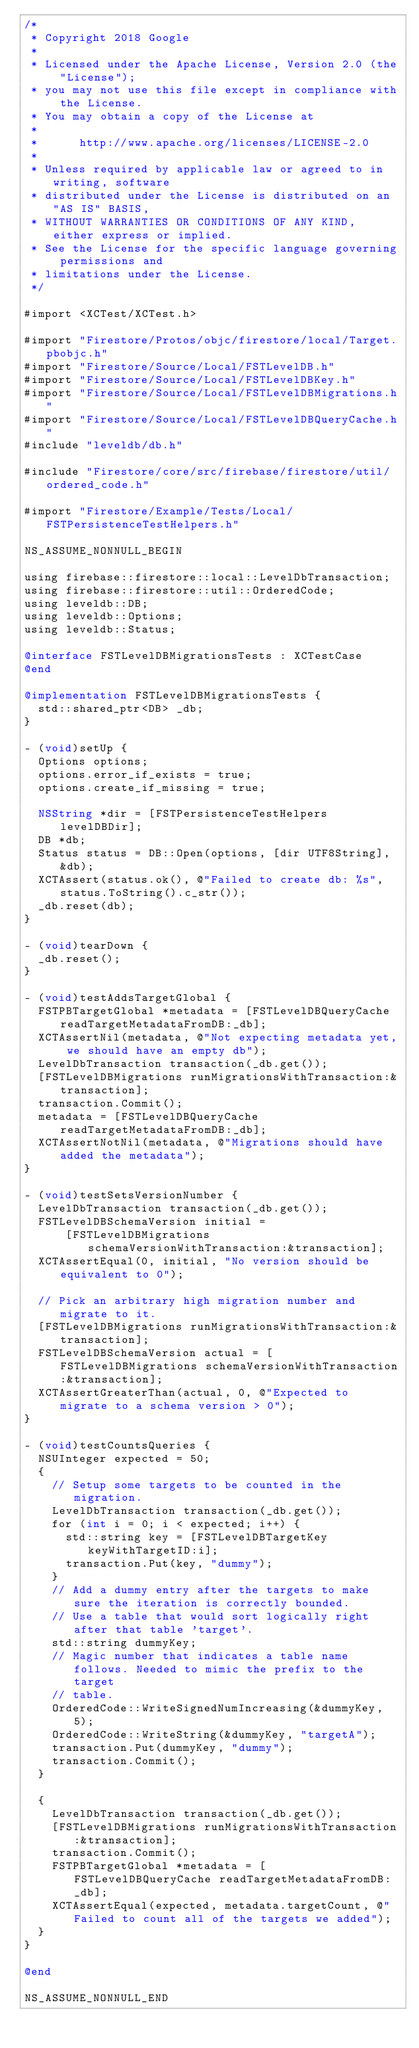Convert code to text. <code><loc_0><loc_0><loc_500><loc_500><_ObjectiveC_>/*
 * Copyright 2018 Google
 *
 * Licensed under the Apache License, Version 2.0 (the "License");
 * you may not use this file except in compliance with the License.
 * You may obtain a copy of the License at
 *
 *      http://www.apache.org/licenses/LICENSE-2.0
 *
 * Unless required by applicable law or agreed to in writing, software
 * distributed under the License is distributed on an "AS IS" BASIS,
 * WITHOUT WARRANTIES OR CONDITIONS OF ANY KIND, either express or implied.
 * See the License for the specific language governing permissions and
 * limitations under the License.
 */

#import <XCTest/XCTest.h>

#import "Firestore/Protos/objc/firestore/local/Target.pbobjc.h"
#import "Firestore/Source/Local/FSTLevelDB.h"
#import "Firestore/Source/Local/FSTLevelDBKey.h"
#import "Firestore/Source/Local/FSTLevelDBMigrations.h"
#import "Firestore/Source/Local/FSTLevelDBQueryCache.h"
#include "leveldb/db.h"

#include "Firestore/core/src/firebase/firestore/util/ordered_code.h"

#import "Firestore/Example/Tests/Local/FSTPersistenceTestHelpers.h"

NS_ASSUME_NONNULL_BEGIN

using firebase::firestore::local::LevelDbTransaction;
using firebase::firestore::util::OrderedCode;
using leveldb::DB;
using leveldb::Options;
using leveldb::Status;

@interface FSTLevelDBMigrationsTests : XCTestCase
@end

@implementation FSTLevelDBMigrationsTests {
  std::shared_ptr<DB> _db;
}

- (void)setUp {
  Options options;
  options.error_if_exists = true;
  options.create_if_missing = true;

  NSString *dir = [FSTPersistenceTestHelpers levelDBDir];
  DB *db;
  Status status = DB::Open(options, [dir UTF8String], &db);
  XCTAssert(status.ok(), @"Failed to create db: %s", status.ToString().c_str());
  _db.reset(db);
}

- (void)tearDown {
  _db.reset();
}

- (void)testAddsTargetGlobal {
  FSTPBTargetGlobal *metadata = [FSTLevelDBQueryCache readTargetMetadataFromDB:_db];
  XCTAssertNil(metadata, @"Not expecting metadata yet, we should have an empty db");
  LevelDbTransaction transaction(_db.get());
  [FSTLevelDBMigrations runMigrationsWithTransaction:&transaction];
  transaction.Commit();
  metadata = [FSTLevelDBQueryCache readTargetMetadataFromDB:_db];
  XCTAssertNotNil(metadata, @"Migrations should have added the metadata");
}

- (void)testSetsVersionNumber {
  LevelDbTransaction transaction(_db.get());
  FSTLevelDBSchemaVersion initial =
      [FSTLevelDBMigrations schemaVersionWithTransaction:&transaction];
  XCTAssertEqual(0, initial, "No version should be equivalent to 0");

  // Pick an arbitrary high migration number and migrate to it.
  [FSTLevelDBMigrations runMigrationsWithTransaction:&transaction];
  FSTLevelDBSchemaVersion actual = [FSTLevelDBMigrations schemaVersionWithTransaction:&transaction];
  XCTAssertGreaterThan(actual, 0, @"Expected to migrate to a schema version > 0");
}

- (void)testCountsQueries {
  NSUInteger expected = 50;
  {
    // Setup some targets to be counted in the migration.
    LevelDbTransaction transaction(_db.get());
    for (int i = 0; i < expected; i++) {
      std::string key = [FSTLevelDBTargetKey keyWithTargetID:i];
      transaction.Put(key, "dummy");
    }
    // Add a dummy entry after the targets to make sure the iteration is correctly bounded.
    // Use a table that would sort logically right after that table 'target'.
    std::string dummyKey;
    // Magic number that indicates a table name follows. Needed to mimic the prefix to the target
    // table.
    OrderedCode::WriteSignedNumIncreasing(&dummyKey, 5);
    OrderedCode::WriteString(&dummyKey, "targetA");
    transaction.Put(dummyKey, "dummy");
    transaction.Commit();
  }

  {
    LevelDbTransaction transaction(_db.get());
    [FSTLevelDBMigrations runMigrationsWithTransaction:&transaction];
    transaction.Commit();
    FSTPBTargetGlobal *metadata = [FSTLevelDBQueryCache readTargetMetadataFromDB:_db];
    XCTAssertEqual(expected, metadata.targetCount, @"Failed to count all of the targets we added");
  }
}

@end

NS_ASSUME_NONNULL_END
</code> 